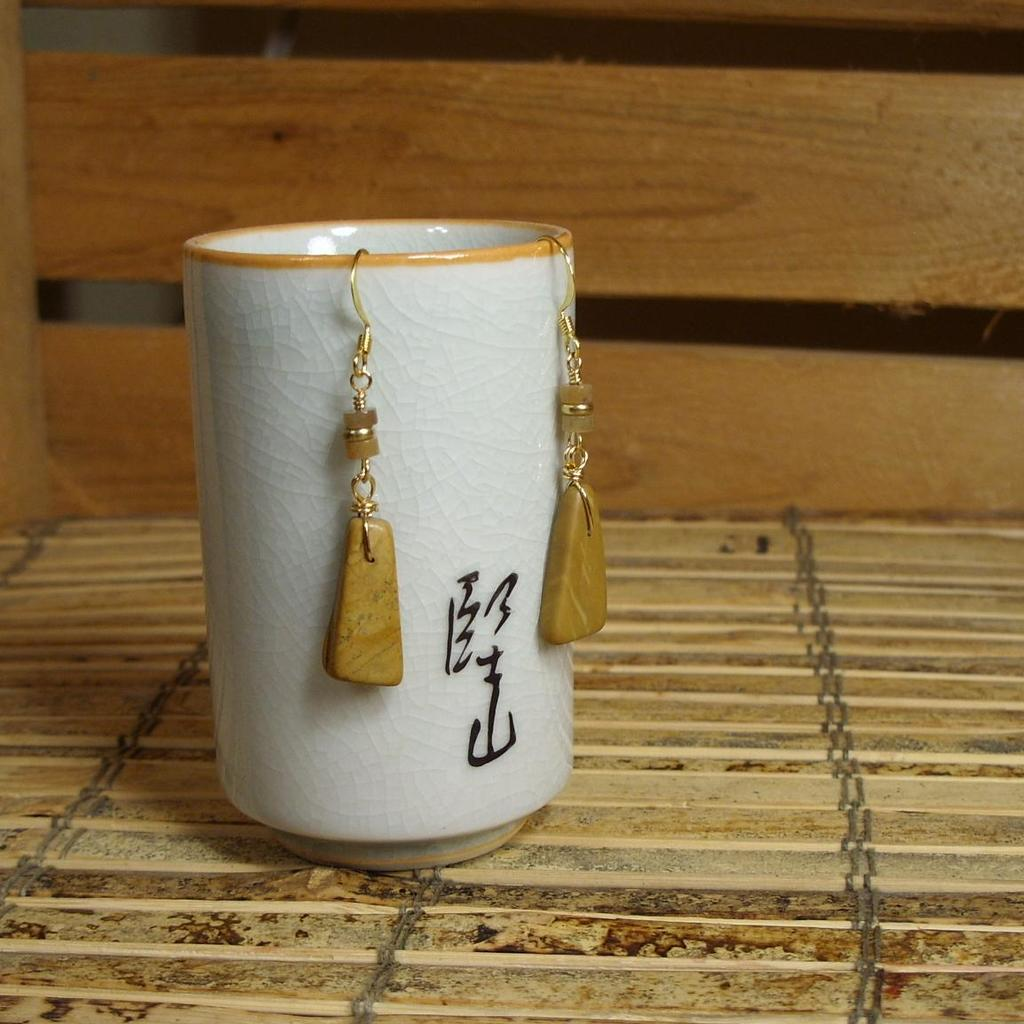What is placed on the wooden surface in the image? There is a cup on a wooden surface in the image. What is on the cup? There are earrings on the cup. What type of material is visible in the background of the image? There are wooden planks visible in the background of the image. How does the cup affect the acoustics in the room in the image? The cup does not affect the acoustics in the room in the image, as it is a stationary object and does not produce or alter sound. 